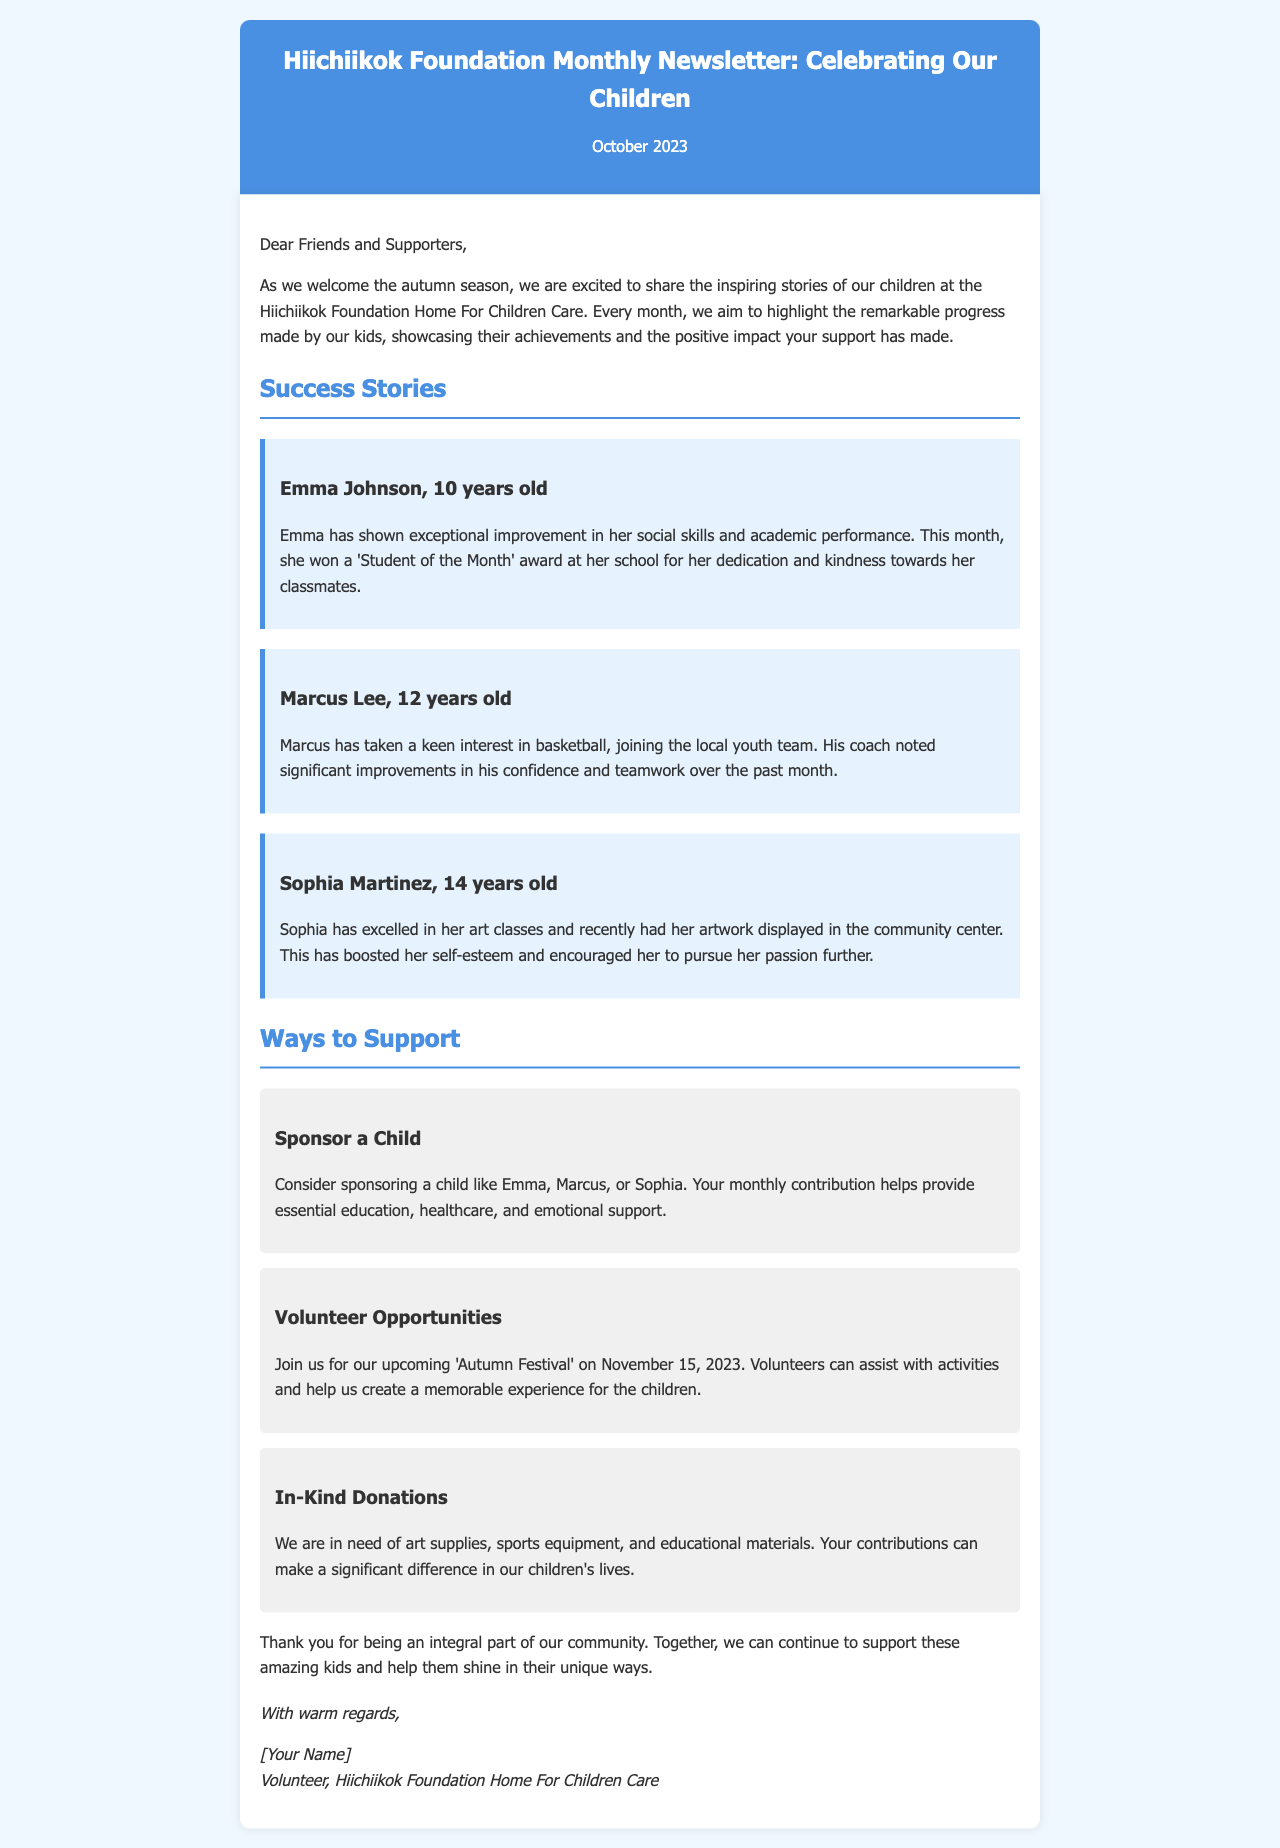What is the title of the newsletter? The title is stated at the beginning of the document, highlighting its purpose and theme for October 2023.
Answer: Hiichiikok Foundation Monthly Newsletter: Celebrating Our Children Who won the 'Student of the Month' award? The newsletter notes this achievement under Emma's success story, mentioning her dedication and kindness.
Answer: Emma Johnson What is Sophia's notable achievement this month? The document details Sophia’s progress in her art classes and her artwork being displayed.
Answer: Artwork displayed in the community center When is the 'Autumn Festival' happening? The date is provided alongside the invitation for volunteer opportunities in the support section.
Answer: November 15, 2023 What are the three types of support mentioned? The document lists specific ways to support the foundation, categorizing them under distinct headings.
Answer: Sponsor a Child, Volunteer Opportunities, In-Kind Donations How old is Marcus Lee? This information is found in the success story section, directly stating his age.
Answer: 12 years old What is the main purpose of the monthly newsletter? The introduction outlines the newsletter's aim to showcase children's progress and support from the community.
Answer: Highlight remarkable progress Who is signing off the letter? The closing section of the newsletter includes the name and title of the person signing it.
Answer: [Your Name] 